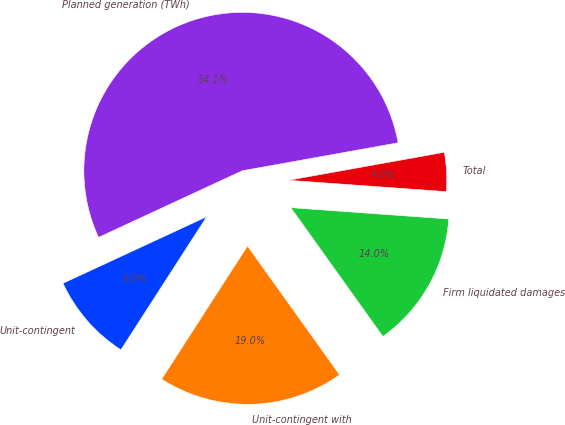<chart> <loc_0><loc_0><loc_500><loc_500><pie_chart><fcel>Unit-contingent<fcel>Unit-contingent with<fcel>Firm liquidated damages<fcel>Total<fcel>Planned generation (TWh)<nl><fcel>8.98%<fcel>18.99%<fcel>13.98%<fcel>3.97%<fcel>54.08%<nl></chart> 